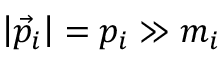<formula> <loc_0><loc_0><loc_500><loc_500>\left | { \vec { p } } _ { i } \right | = p _ { i } \gg m _ { i }</formula> 